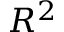<formula> <loc_0><loc_0><loc_500><loc_500>R ^ { 2 }</formula> 